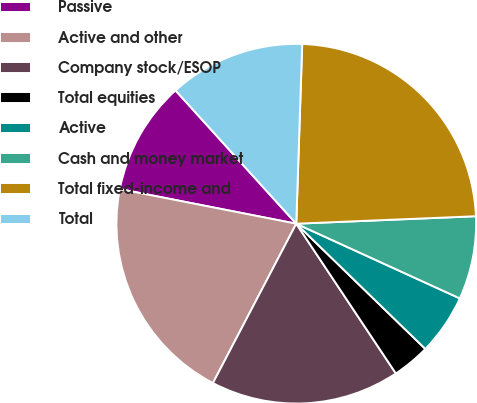Convert chart to OTSL. <chart><loc_0><loc_0><loc_500><loc_500><pie_chart><fcel>Passive<fcel>Active and other<fcel>Company stock/ESOP<fcel>Total equities<fcel>Active<fcel>Cash and money market<fcel>Total fixed-income and<fcel>Total<nl><fcel>10.2%<fcel>20.41%<fcel>17.01%<fcel>3.4%<fcel>5.44%<fcel>7.48%<fcel>23.81%<fcel>12.24%<nl></chart> 